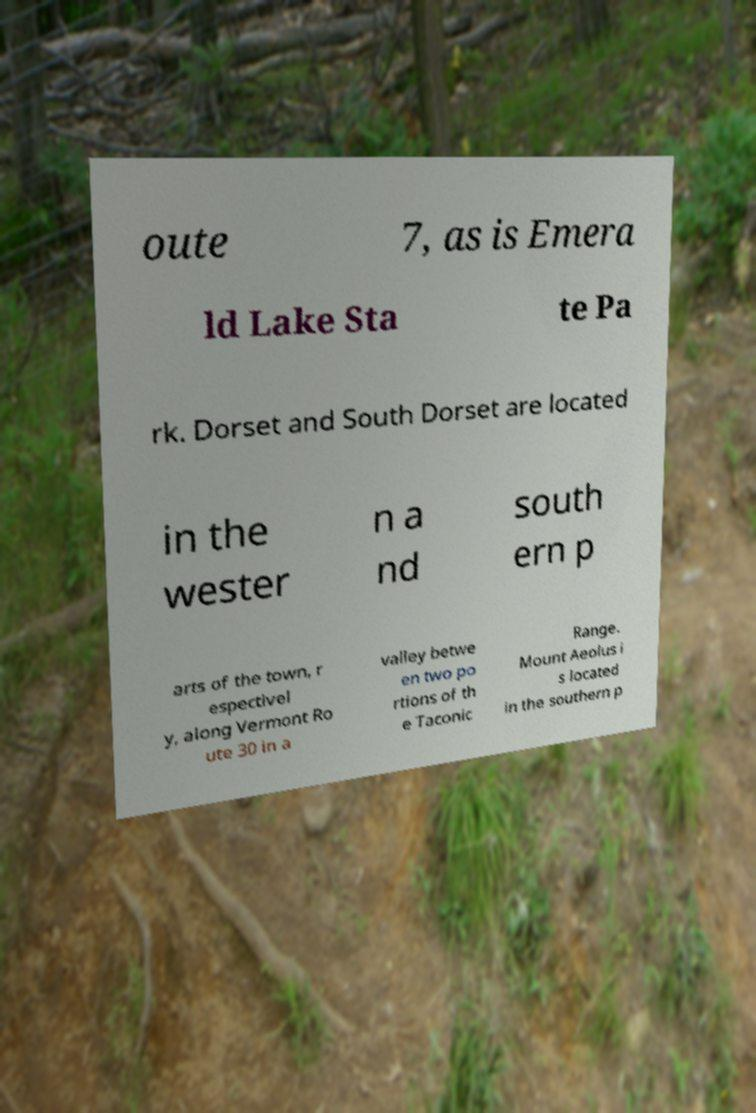Can you accurately transcribe the text from the provided image for me? oute 7, as is Emera ld Lake Sta te Pa rk. Dorset and South Dorset are located in the wester n a nd south ern p arts of the town, r espectivel y, along Vermont Ro ute 30 in a valley betwe en two po rtions of th e Taconic Range. Mount Aeolus i s located in the southern p 